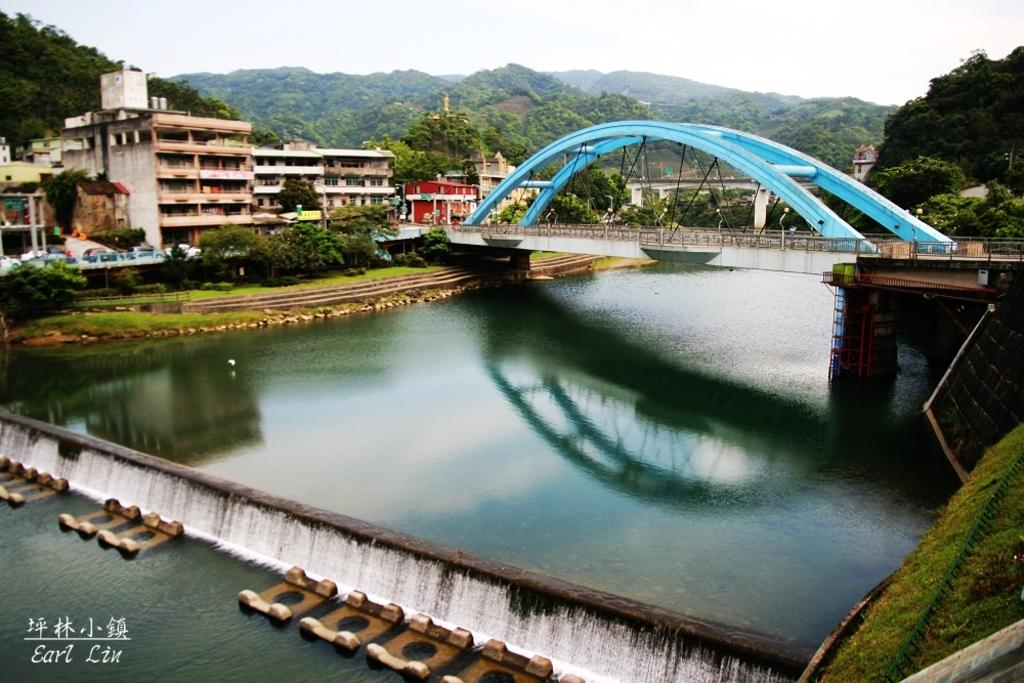What is the main structure in the image? There is a bridge in the image. What is the bridge positioned over? The bridge is over a river. What else can be seen in the image besides the bridge? There are buildings, trees, the ground, hills, and fences visible in the image. What part of the natural environment is visible in the image? The sky is visible in the image. What type of cabbage can be seen growing on the hills in the image? There is no cabbage present in the image; the hills are covered with vegetation but no specific crops are identifiable. Can you tell me how many volleyballs are visible in the image? There are no volleyballs present in the image. 